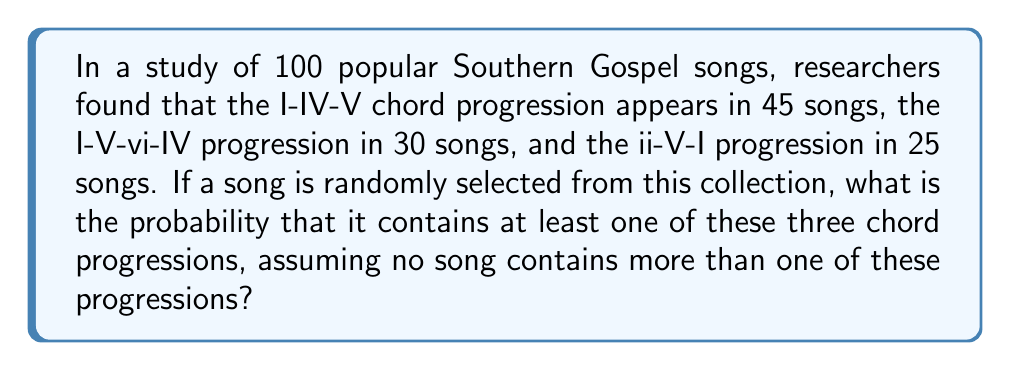Give your solution to this math problem. To solve this problem, we'll use the addition principle of probability, since we're dealing with mutually exclusive events (as per the assumption that no song contains more than one of these progressions).

Let's define our events:
A: Song contains I-IV-V progression
B: Song contains I-V-vi-IV progression
C: Song contains ii-V-I progression

We're given:
P(A) = 45/100 = 0.45
P(B) = 30/100 = 0.30
P(C) = 25/100 = 0.25

The probability of a song containing at least one of these progressions is the sum of the individual probabilities:

$$P(\text{at least one}) = P(A) + P(B) + P(C)$$

Substituting the values:

$$P(\text{at least one}) = 0.45 + 0.30 + 0.25 = 1.00$$

This result makes sense in the context of Southern Gospel music, as these chord progressions are fundamental to the genre and it's common for songs to use at least one of them.
Answer: The probability is 1.00 or 100%. 